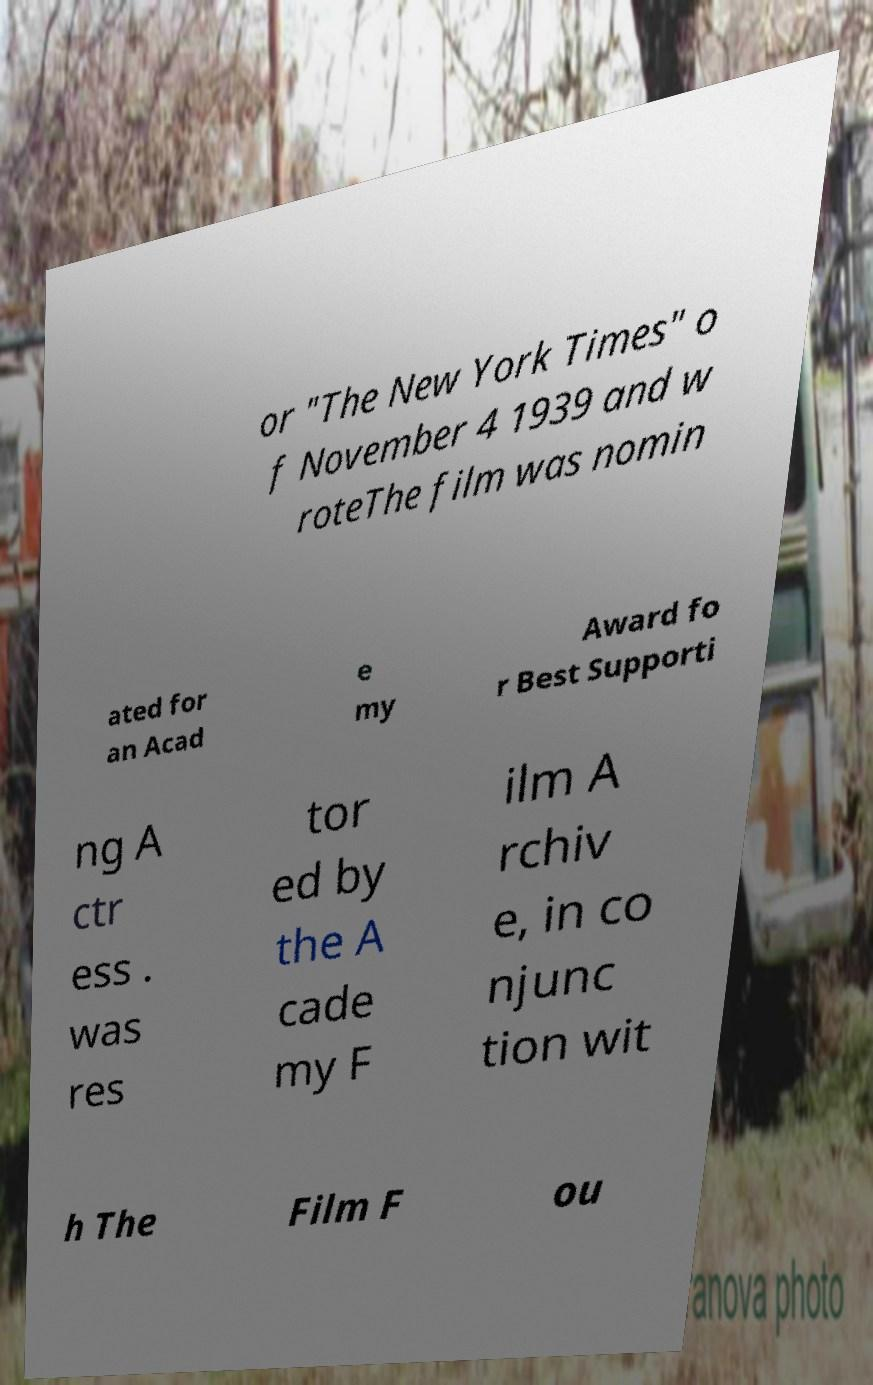For documentation purposes, I need the text within this image transcribed. Could you provide that? or "The New York Times" o f November 4 1939 and w roteThe film was nomin ated for an Acad e my Award fo r Best Supporti ng A ctr ess . was res tor ed by the A cade my F ilm A rchiv e, in co njunc tion wit h The Film F ou 